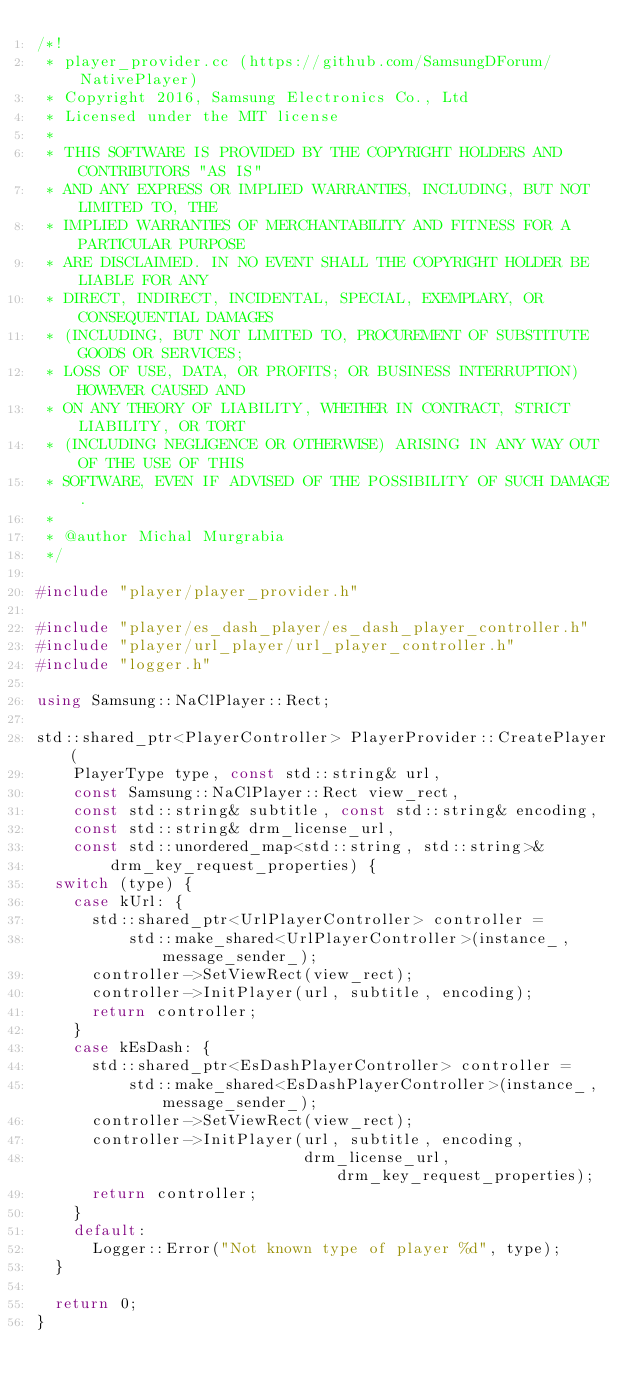Convert code to text. <code><loc_0><loc_0><loc_500><loc_500><_C++_>/*!
 * player_provider.cc (https://github.com/SamsungDForum/NativePlayer)
 * Copyright 2016, Samsung Electronics Co., Ltd
 * Licensed under the MIT license
 *
 * THIS SOFTWARE IS PROVIDED BY THE COPYRIGHT HOLDERS AND CONTRIBUTORS "AS IS"
 * AND ANY EXPRESS OR IMPLIED WARRANTIES, INCLUDING, BUT NOT LIMITED TO, THE
 * IMPLIED WARRANTIES OF MERCHANTABILITY AND FITNESS FOR A PARTICULAR PURPOSE
 * ARE DISCLAIMED. IN NO EVENT SHALL THE COPYRIGHT HOLDER BE LIABLE FOR ANY
 * DIRECT, INDIRECT, INCIDENTAL, SPECIAL, EXEMPLARY, OR CONSEQUENTIAL DAMAGES
 * (INCLUDING, BUT NOT LIMITED TO, PROCUREMENT OF SUBSTITUTE GOODS OR SERVICES;
 * LOSS OF USE, DATA, OR PROFITS; OR BUSINESS INTERRUPTION) HOWEVER CAUSED AND
 * ON ANY THEORY OF LIABILITY, WHETHER IN CONTRACT, STRICT LIABILITY, OR TORT
 * (INCLUDING NEGLIGENCE OR OTHERWISE) ARISING IN ANY WAY OUT OF THE USE OF THIS
 * SOFTWARE, EVEN IF ADVISED OF THE POSSIBILITY OF SUCH DAMAGE.
 *
 * @author Michal Murgrabia
 */

#include "player/player_provider.h"

#include "player/es_dash_player/es_dash_player_controller.h"
#include "player/url_player/url_player_controller.h"
#include "logger.h"

using Samsung::NaClPlayer::Rect;

std::shared_ptr<PlayerController> PlayerProvider::CreatePlayer(
    PlayerType type, const std::string& url,
    const Samsung::NaClPlayer::Rect view_rect,
    const std::string& subtitle, const std::string& encoding,
    const std::string& drm_license_url,
    const std::unordered_map<std::string, std::string>&
        drm_key_request_properties) {
  switch (type) {
    case kUrl: {
      std::shared_ptr<UrlPlayerController> controller =
          std::make_shared<UrlPlayerController>(instance_, message_sender_);
      controller->SetViewRect(view_rect);
      controller->InitPlayer(url, subtitle, encoding);
      return controller;
    }
    case kEsDash: {
      std::shared_ptr<EsDashPlayerController> controller =
          std::make_shared<EsDashPlayerController>(instance_, message_sender_);
      controller->SetViewRect(view_rect);
      controller->InitPlayer(url, subtitle, encoding,
                             drm_license_url, drm_key_request_properties);
      return controller;
    }
    default:
      Logger::Error("Not known type of player %d", type);
  }

  return 0;
}
</code> 